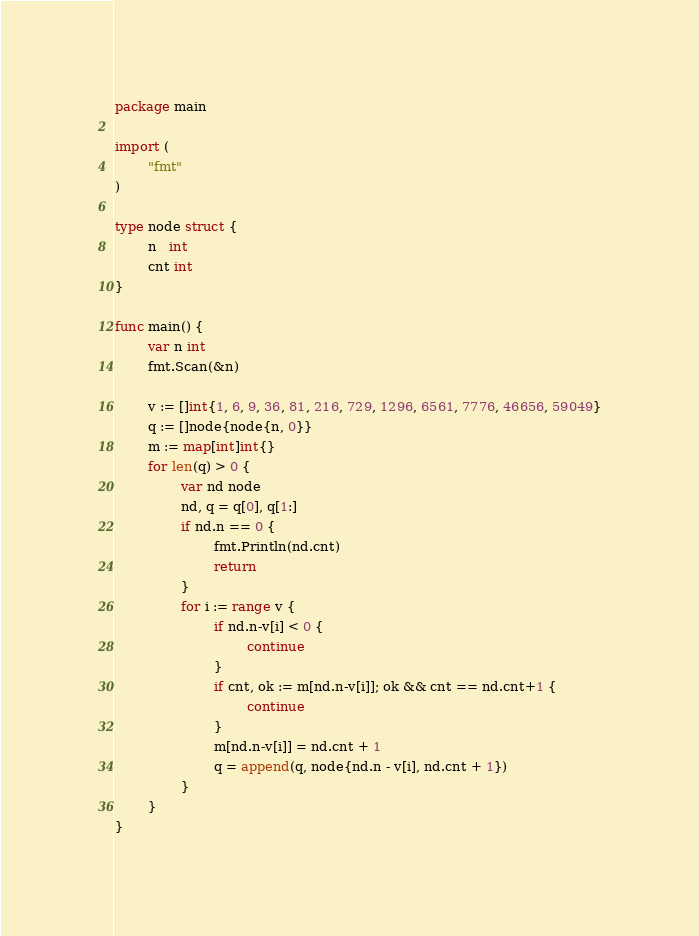<code> <loc_0><loc_0><loc_500><loc_500><_Go_>package main

import (
        "fmt"
)

type node struct {
        n   int
        cnt int
}

func main() {
        var n int
        fmt.Scan(&n)

        v := []int{1, 6, 9, 36, 81, 216, 729, 1296, 6561, 7776, 46656, 59049}
        q := []node{node{n, 0}}
        m := map[int]int{}
        for len(q) > 0 {
                var nd node
                nd, q = q[0], q[1:]
                if nd.n == 0 {
                        fmt.Println(nd.cnt)
                        return
                }
                for i := range v {
                        if nd.n-v[i] < 0 {
                                continue
                        }
                        if cnt, ok := m[nd.n-v[i]]; ok && cnt == nd.cnt+1 {
                                continue
                        }
                        m[nd.n-v[i]] = nd.cnt + 1
                        q = append(q, node{nd.n - v[i], nd.cnt + 1})
                }
        }
}</code> 